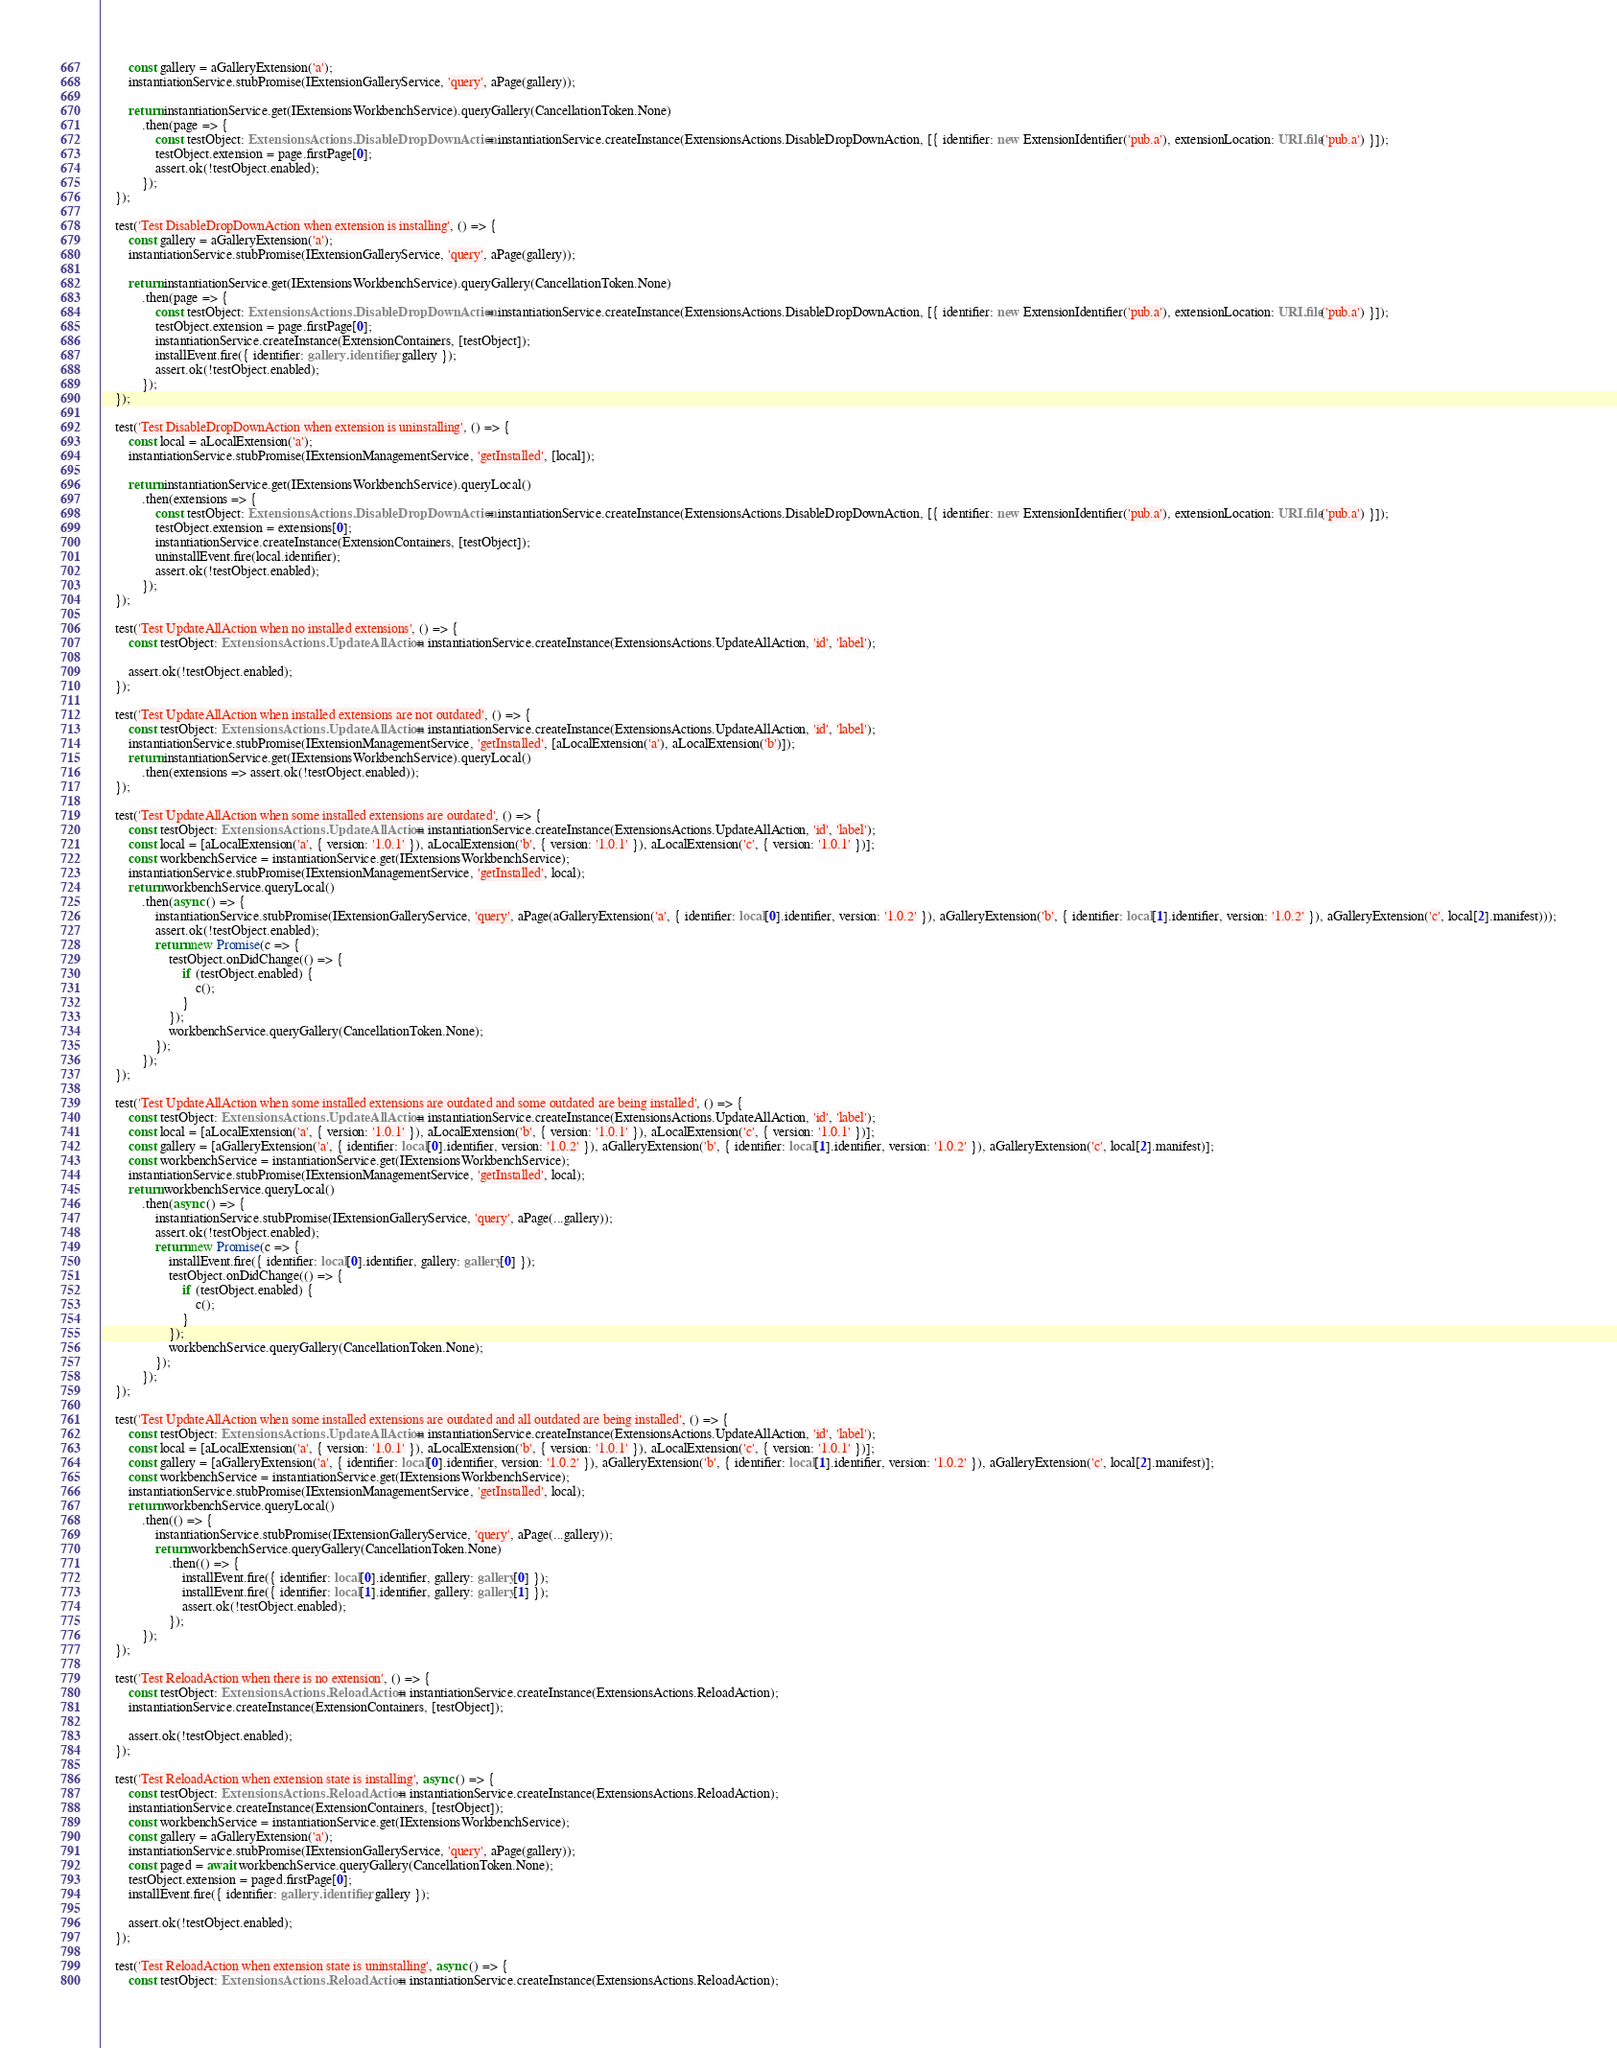Convert code to text. <code><loc_0><loc_0><loc_500><loc_500><_TypeScript_>		const gallery = aGalleryExtension('a');
		instantiationService.stubPromise(IExtensionGalleryService, 'query', aPage(gallery));

		return instantiationService.get(IExtensionsWorkbenchService).queryGallery(CancellationToken.None)
			.then(page => {
				const testObject: ExtensionsActions.DisableDropDownAction = instantiationService.createInstance(ExtensionsActions.DisableDropDownAction, [{ identifier: new ExtensionIdentifier('pub.a'), extensionLocation: URI.file('pub.a') }]);
				testObject.extension = page.firstPage[0];
				assert.ok(!testObject.enabled);
			});
	});

	test('Test DisableDropDownAction when extension is installing', () => {
		const gallery = aGalleryExtension('a');
		instantiationService.stubPromise(IExtensionGalleryService, 'query', aPage(gallery));

		return instantiationService.get(IExtensionsWorkbenchService).queryGallery(CancellationToken.None)
			.then(page => {
				const testObject: ExtensionsActions.DisableDropDownAction = instantiationService.createInstance(ExtensionsActions.DisableDropDownAction, [{ identifier: new ExtensionIdentifier('pub.a'), extensionLocation: URI.file('pub.a') }]);
				testObject.extension = page.firstPage[0];
				instantiationService.createInstance(ExtensionContainers, [testObject]);
				installEvent.fire({ identifier: gallery.identifier, gallery });
				assert.ok(!testObject.enabled);
			});
	});

	test('Test DisableDropDownAction when extension is uninstalling', () => {
		const local = aLocalExtension('a');
		instantiationService.stubPromise(IExtensionManagementService, 'getInstalled', [local]);

		return instantiationService.get(IExtensionsWorkbenchService).queryLocal()
			.then(extensions => {
				const testObject: ExtensionsActions.DisableDropDownAction = instantiationService.createInstance(ExtensionsActions.DisableDropDownAction, [{ identifier: new ExtensionIdentifier('pub.a'), extensionLocation: URI.file('pub.a') }]);
				testObject.extension = extensions[0];
				instantiationService.createInstance(ExtensionContainers, [testObject]);
				uninstallEvent.fire(local.identifier);
				assert.ok(!testObject.enabled);
			});
	});

	test('Test UpdateAllAction when no installed extensions', () => {
		const testObject: ExtensionsActions.UpdateAllAction = instantiationService.createInstance(ExtensionsActions.UpdateAllAction, 'id', 'label');

		assert.ok(!testObject.enabled);
	});

	test('Test UpdateAllAction when installed extensions are not outdated', () => {
		const testObject: ExtensionsActions.UpdateAllAction = instantiationService.createInstance(ExtensionsActions.UpdateAllAction, 'id', 'label');
		instantiationService.stubPromise(IExtensionManagementService, 'getInstalled', [aLocalExtension('a'), aLocalExtension('b')]);
		return instantiationService.get(IExtensionsWorkbenchService).queryLocal()
			.then(extensions => assert.ok(!testObject.enabled));
	});

	test('Test UpdateAllAction when some installed extensions are outdated', () => {
		const testObject: ExtensionsActions.UpdateAllAction = instantiationService.createInstance(ExtensionsActions.UpdateAllAction, 'id', 'label');
		const local = [aLocalExtension('a', { version: '1.0.1' }), aLocalExtension('b', { version: '1.0.1' }), aLocalExtension('c', { version: '1.0.1' })];
		const workbenchService = instantiationService.get(IExtensionsWorkbenchService);
		instantiationService.stubPromise(IExtensionManagementService, 'getInstalled', local);
		return workbenchService.queryLocal()
			.then(async () => {
				instantiationService.stubPromise(IExtensionGalleryService, 'query', aPage(aGalleryExtension('a', { identifier: local[0].identifier, version: '1.0.2' }), aGalleryExtension('b', { identifier: local[1].identifier, version: '1.0.2' }), aGalleryExtension('c', local[2].manifest)));
				assert.ok(!testObject.enabled);
				return new Promise(c => {
					testObject.onDidChange(() => {
						if (testObject.enabled) {
							c();
						}
					});
					workbenchService.queryGallery(CancellationToken.None);
				});
			});
	});

	test('Test UpdateAllAction when some installed extensions are outdated and some outdated are being installed', () => {
		const testObject: ExtensionsActions.UpdateAllAction = instantiationService.createInstance(ExtensionsActions.UpdateAllAction, 'id', 'label');
		const local = [aLocalExtension('a', { version: '1.0.1' }), aLocalExtension('b', { version: '1.0.1' }), aLocalExtension('c', { version: '1.0.1' })];
		const gallery = [aGalleryExtension('a', { identifier: local[0].identifier, version: '1.0.2' }), aGalleryExtension('b', { identifier: local[1].identifier, version: '1.0.2' }), aGalleryExtension('c', local[2].manifest)];
		const workbenchService = instantiationService.get(IExtensionsWorkbenchService);
		instantiationService.stubPromise(IExtensionManagementService, 'getInstalled', local);
		return workbenchService.queryLocal()
			.then(async () => {
				instantiationService.stubPromise(IExtensionGalleryService, 'query', aPage(...gallery));
				assert.ok(!testObject.enabled);
				return new Promise(c => {
					installEvent.fire({ identifier: local[0].identifier, gallery: gallery[0] });
					testObject.onDidChange(() => {
						if (testObject.enabled) {
							c();
						}
					});
					workbenchService.queryGallery(CancellationToken.None);
				});
			});
	});

	test('Test UpdateAllAction when some installed extensions are outdated and all outdated are being installed', () => {
		const testObject: ExtensionsActions.UpdateAllAction = instantiationService.createInstance(ExtensionsActions.UpdateAllAction, 'id', 'label');
		const local = [aLocalExtension('a', { version: '1.0.1' }), aLocalExtension('b', { version: '1.0.1' }), aLocalExtension('c', { version: '1.0.1' })];
		const gallery = [aGalleryExtension('a', { identifier: local[0].identifier, version: '1.0.2' }), aGalleryExtension('b', { identifier: local[1].identifier, version: '1.0.2' }), aGalleryExtension('c', local[2].manifest)];
		const workbenchService = instantiationService.get(IExtensionsWorkbenchService);
		instantiationService.stubPromise(IExtensionManagementService, 'getInstalled', local);
		return workbenchService.queryLocal()
			.then(() => {
				instantiationService.stubPromise(IExtensionGalleryService, 'query', aPage(...gallery));
				return workbenchService.queryGallery(CancellationToken.None)
					.then(() => {
						installEvent.fire({ identifier: local[0].identifier, gallery: gallery[0] });
						installEvent.fire({ identifier: local[1].identifier, gallery: gallery[1] });
						assert.ok(!testObject.enabled);
					});
			});
	});

	test('Test ReloadAction when there is no extension', () => {
		const testObject: ExtensionsActions.ReloadAction = instantiationService.createInstance(ExtensionsActions.ReloadAction);
		instantiationService.createInstance(ExtensionContainers, [testObject]);

		assert.ok(!testObject.enabled);
	});

	test('Test ReloadAction when extension state is installing', async () => {
		const testObject: ExtensionsActions.ReloadAction = instantiationService.createInstance(ExtensionsActions.ReloadAction);
		instantiationService.createInstance(ExtensionContainers, [testObject]);
		const workbenchService = instantiationService.get(IExtensionsWorkbenchService);
		const gallery = aGalleryExtension('a');
		instantiationService.stubPromise(IExtensionGalleryService, 'query', aPage(gallery));
		const paged = await workbenchService.queryGallery(CancellationToken.None);
		testObject.extension = paged.firstPage[0];
		installEvent.fire({ identifier: gallery.identifier, gallery });

		assert.ok(!testObject.enabled);
	});

	test('Test ReloadAction when extension state is uninstalling', async () => {
		const testObject: ExtensionsActions.ReloadAction = instantiationService.createInstance(ExtensionsActions.ReloadAction);</code> 